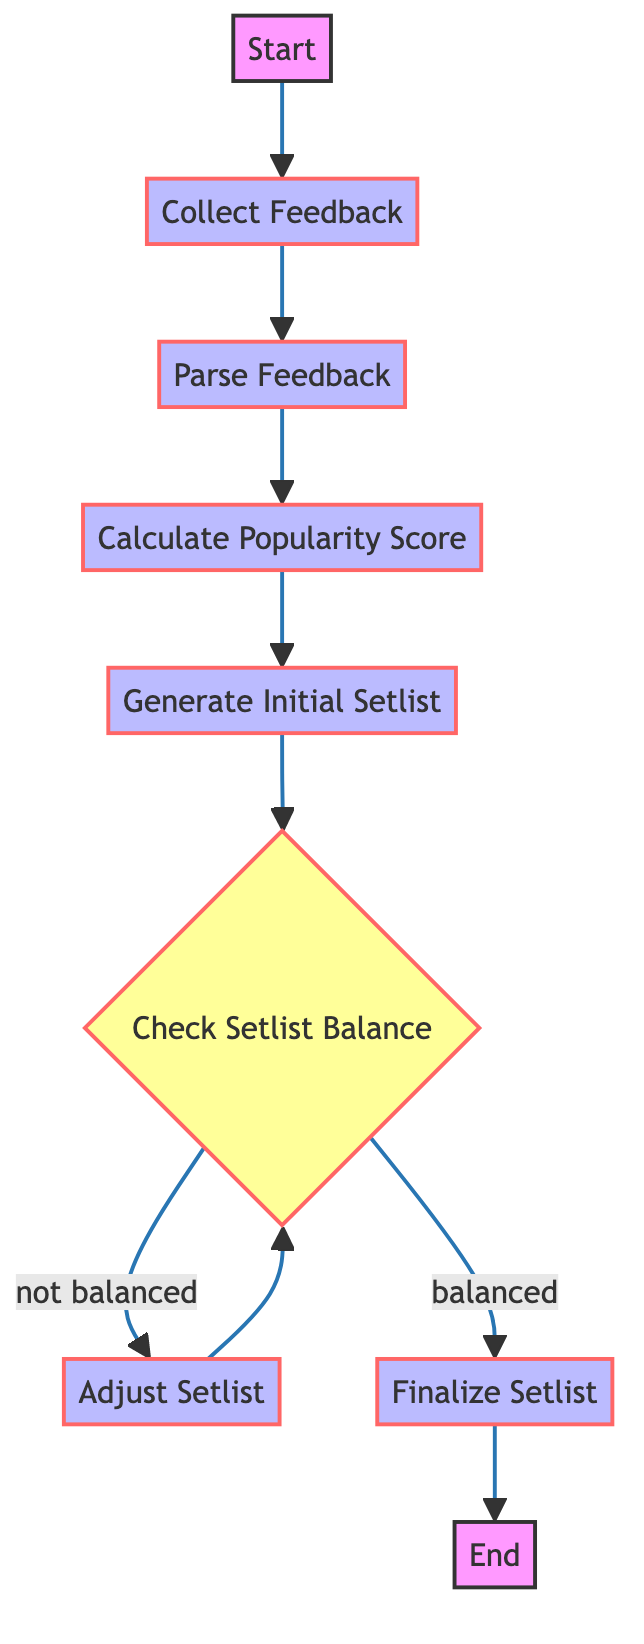What's the first step in the process? The diagram starts with the "Start" node, which is followed by "Collect Feedback." This indicates that collecting feedback is the first action that takes place in the flow.
Answer: Collect Feedback How many processes are in the diagram? The diagram consists of a total of five process nodes: "Collect Feedback," "Parse Feedback," "Calculate Popularity Score," "Generate Initial Setlist," and "Adjust Setlist." These processes represent actions taken to create the setlist generator.
Answer: Five What happens if the setlist is balanced? According to the flowchart, if the setlist is balanced, the next step is to "Finalize Setlist." This indicates that a balanced setlist allows the process to move forward without adjustments.
Answer: Finalize Setlist Which node comes after "Parse Feedback"? "Calculate Popularity Score" comes directly after "Parse Feedback" in the flow of the diagram. This shows that after parsing feedback, the next logical step is calculating how popular songs are among the audience.
Answer: Calculate Popularity Score What is the condition for adjusting the setlist? The condition for adjusting the setlist is if it is "not balanced." This means that an unbalanced setlist triggers the need for adjustments to improve the mix of songs.
Answer: Not balanced How many decision points are in the flowchart? The flowchart has one decision point, which is "Check Setlist Balance." This decision dictates the path of the flow based on whether the setlist is balanced or not.
Answer: One What is the last step before the end of the process? The last step before reaching the "End" of the process is "Finalize Setlist." This indicates that finalizing the setlist is the concluding action of the flowchart before ending.
Answer: Finalize Setlist What action follows "Adjust Setlist"? After "Adjust Setlist," the action that follows is "Check Setlist Balance." This shows that adjustments must be evaluated again to see if the setlist is now balanced.
Answer: Check Setlist Balance What type of feedback is collected? Audience feedback is collected from multiple sources such as social media, surveys, and previous concert reviews. This helps to understand audience preferences in selecting songs.
Answer: Audience feedback 